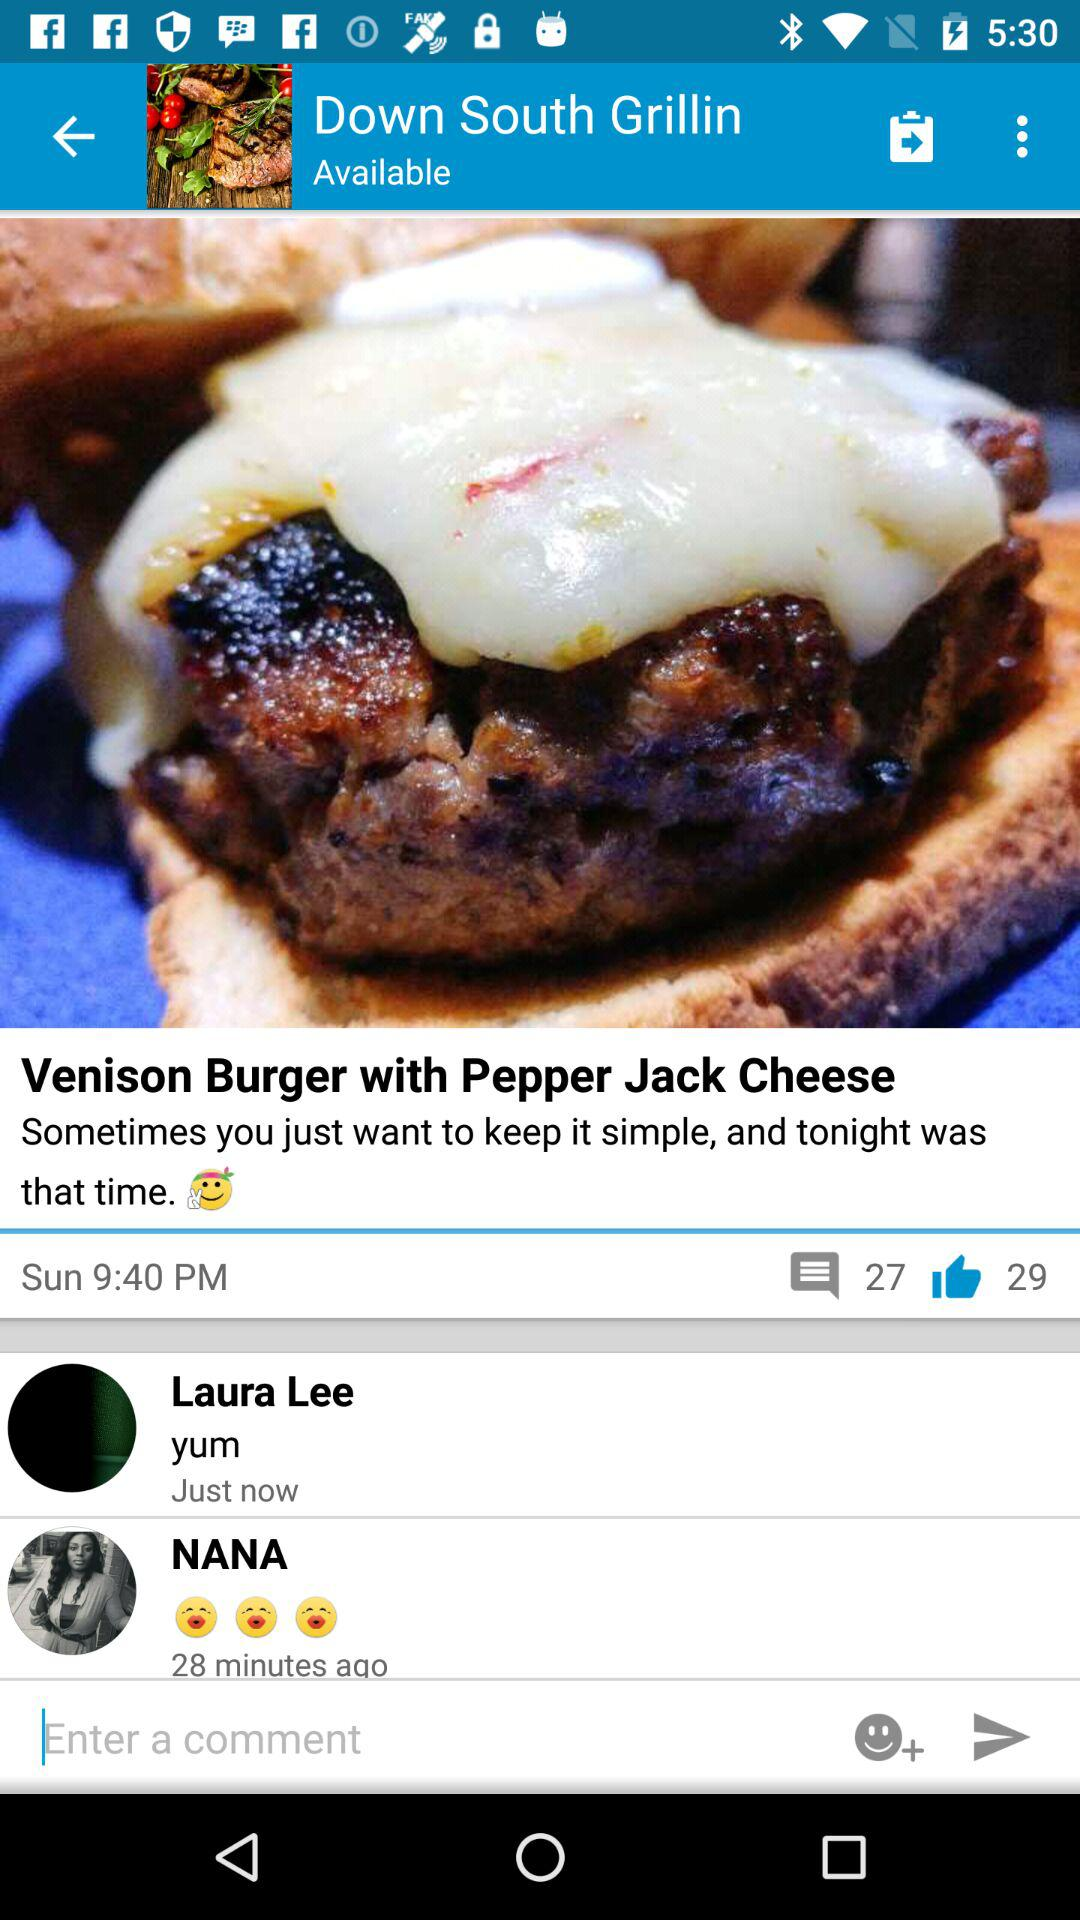How many people like the "Venison Burger with Pepper Jack Cheese"? The number of people who like the "Venison Burger with Pepper Jack Cheese" is 29. 